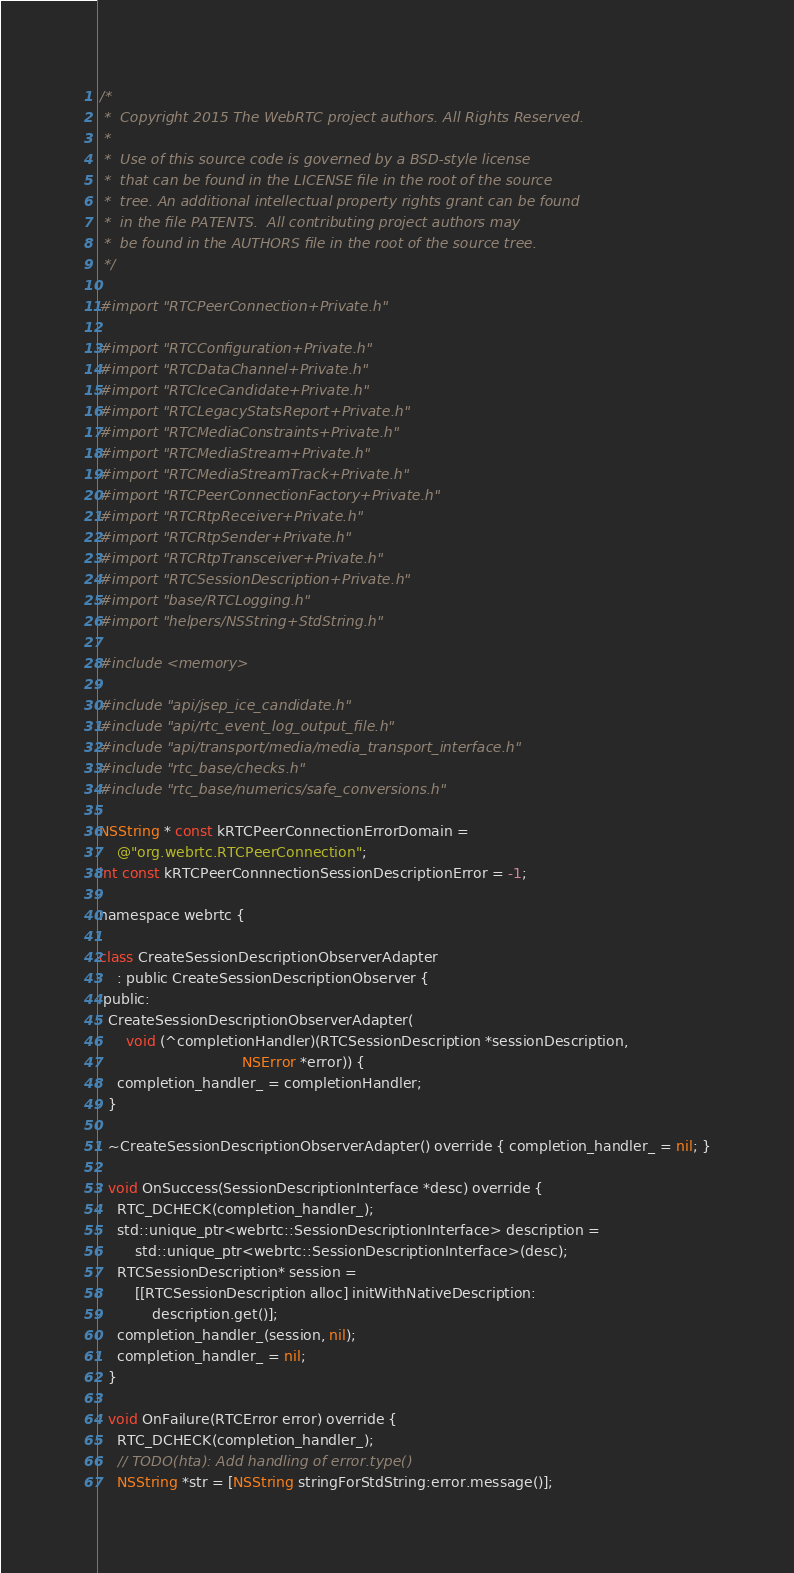<code> <loc_0><loc_0><loc_500><loc_500><_ObjectiveC_>/*
 *  Copyright 2015 The WebRTC project authors. All Rights Reserved.
 *
 *  Use of this source code is governed by a BSD-style license
 *  that can be found in the LICENSE file in the root of the source
 *  tree. An additional intellectual property rights grant can be found
 *  in the file PATENTS.  All contributing project authors may
 *  be found in the AUTHORS file in the root of the source tree.
 */

#import "RTCPeerConnection+Private.h"

#import "RTCConfiguration+Private.h"
#import "RTCDataChannel+Private.h"
#import "RTCIceCandidate+Private.h"
#import "RTCLegacyStatsReport+Private.h"
#import "RTCMediaConstraints+Private.h"
#import "RTCMediaStream+Private.h"
#import "RTCMediaStreamTrack+Private.h"
#import "RTCPeerConnectionFactory+Private.h"
#import "RTCRtpReceiver+Private.h"
#import "RTCRtpSender+Private.h"
#import "RTCRtpTransceiver+Private.h"
#import "RTCSessionDescription+Private.h"
#import "base/RTCLogging.h"
#import "helpers/NSString+StdString.h"

#include <memory>

#include "api/jsep_ice_candidate.h"
#include "api/rtc_event_log_output_file.h"
#include "api/transport/media/media_transport_interface.h"
#include "rtc_base/checks.h"
#include "rtc_base/numerics/safe_conversions.h"

NSString * const kRTCPeerConnectionErrorDomain =
    @"org.webrtc.RTCPeerConnection";
int const kRTCPeerConnnectionSessionDescriptionError = -1;

namespace webrtc {

class CreateSessionDescriptionObserverAdapter
    : public CreateSessionDescriptionObserver {
 public:
  CreateSessionDescriptionObserverAdapter(
      void (^completionHandler)(RTCSessionDescription *sessionDescription,
                                NSError *error)) {
    completion_handler_ = completionHandler;
  }

  ~CreateSessionDescriptionObserverAdapter() override { completion_handler_ = nil; }

  void OnSuccess(SessionDescriptionInterface *desc) override {
    RTC_DCHECK(completion_handler_);
    std::unique_ptr<webrtc::SessionDescriptionInterface> description =
        std::unique_ptr<webrtc::SessionDescriptionInterface>(desc);
    RTCSessionDescription* session =
        [[RTCSessionDescription alloc] initWithNativeDescription:
            description.get()];
    completion_handler_(session, nil);
    completion_handler_ = nil;
  }

  void OnFailure(RTCError error) override {
    RTC_DCHECK(completion_handler_);
    // TODO(hta): Add handling of error.type()
    NSString *str = [NSString stringForStdString:error.message()];</code> 